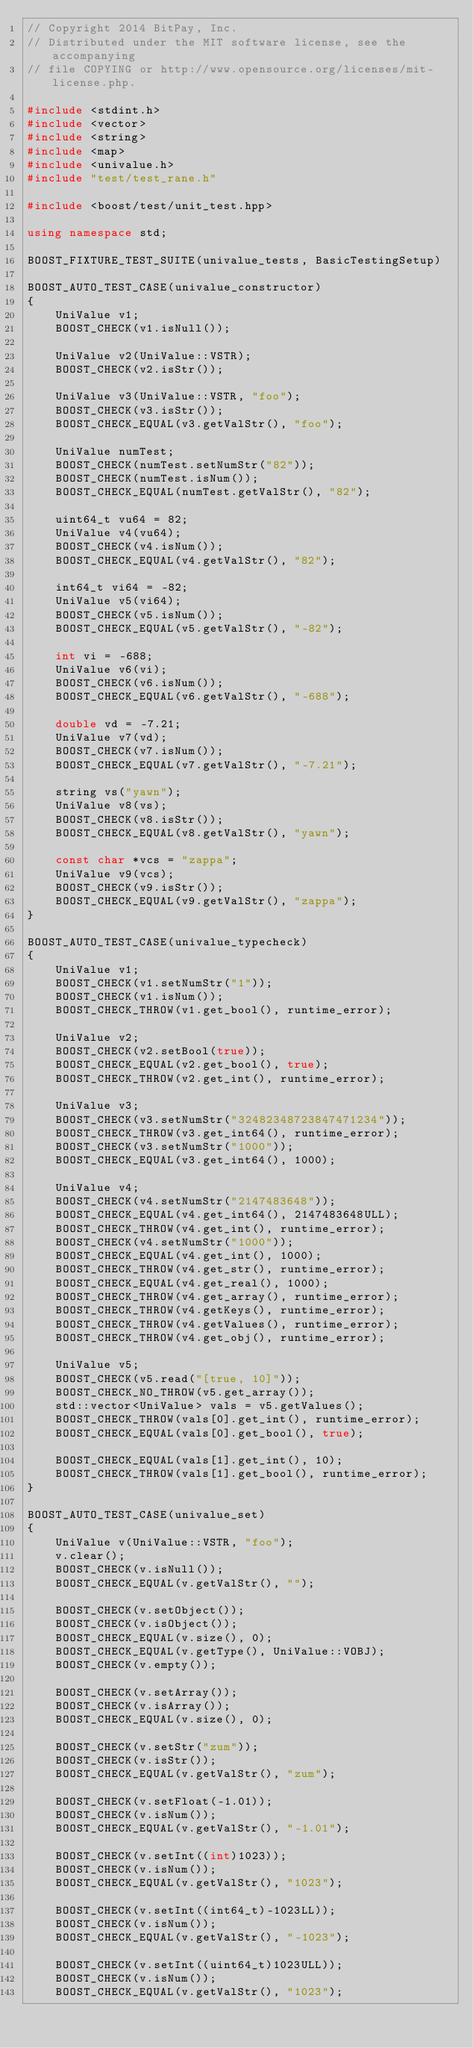Convert code to text. <code><loc_0><loc_0><loc_500><loc_500><_C++_>// Copyright 2014 BitPay, Inc.
// Distributed under the MIT software license, see the accompanying
// file COPYING or http://www.opensource.org/licenses/mit-license.php.

#include <stdint.h>
#include <vector>
#include <string>
#include <map>
#include <univalue.h>
#include "test/test_rane.h"

#include <boost/test/unit_test.hpp>

using namespace std;

BOOST_FIXTURE_TEST_SUITE(univalue_tests, BasicTestingSetup)

BOOST_AUTO_TEST_CASE(univalue_constructor)
{
    UniValue v1;
    BOOST_CHECK(v1.isNull());

    UniValue v2(UniValue::VSTR);
    BOOST_CHECK(v2.isStr());

    UniValue v3(UniValue::VSTR, "foo");
    BOOST_CHECK(v3.isStr());
    BOOST_CHECK_EQUAL(v3.getValStr(), "foo");

    UniValue numTest;
    BOOST_CHECK(numTest.setNumStr("82"));
    BOOST_CHECK(numTest.isNum());
    BOOST_CHECK_EQUAL(numTest.getValStr(), "82");

    uint64_t vu64 = 82;
    UniValue v4(vu64);
    BOOST_CHECK(v4.isNum());
    BOOST_CHECK_EQUAL(v4.getValStr(), "82");

    int64_t vi64 = -82;
    UniValue v5(vi64);
    BOOST_CHECK(v5.isNum());
    BOOST_CHECK_EQUAL(v5.getValStr(), "-82");

    int vi = -688;
    UniValue v6(vi);
    BOOST_CHECK(v6.isNum());
    BOOST_CHECK_EQUAL(v6.getValStr(), "-688");

    double vd = -7.21;
    UniValue v7(vd);
    BOOST_CHECK(v7.isNum());
    BOOST_CHECK_EQUAL(v7.getValStr(), "-7.21");

    string vs("yawn");
    UniValue v8(vs);
    BOOST_CHECK(v8.isStr());
    BOOST_CHECK_EQUAL(v8.getValStr(), "yawn");

    const char *vcs = "zappa";
    UniValue v9(vcs);
    BOOST_CHECK(v9.isStr());
    BOOST_CHECK_EQUAL(v9.getValStr(), "zappa");
}

BOOST_AUTO_TEST_CASE(univalue_typecheck)
{
    UniValue v1;
    BOOST_CHECK(v1.setNumStr("1"));
    BOOST_CHECK(v1.isNum());
    BOOST_CHECK_THROW(v1.get_bool(), runtime_error);

    UniValue v2;
    BOOST_CHECK(v2.setBool(true));
    BOOST_CHECK_EQUAL(v2.get_bool(), true);
    BOOST_CHECK_THROW(v2.get_int(), runtime_error);

    UniValue v3;
    BOOST_CHECK(v3.setNumStr("32482348723847471234"));
    BOOST_CHECK_THROW(v3.get_int64(), runtime_error);
    BOOST_CHECK(v3.setNumStr("1000"));
    BOOST_CHECK_EQUAL(v3.get_int64(), 1000);

    UniValue v4;
    BOOST_CHECK(v4.setNumStr("2147483648"));
    BOOST_CHECK_EQUAL(v4.get_int64(), 2147483648ULL);
    BOOST_CHECK_THROW(v4.get_int(), runtime_error);
    BOOST_CHECK(v4.setNumStr("1000"));
    BOOST_CHECK_EQUAL(v4.get_int(), 1000);
    BOOST_CHECK_THROW(v4.get_str(), runtime_error);
    BOOST_CHECK_EQUAL(v4.get_real(), 1000);
    BOOST_CHECK_THROW(v4.get_array(), runtime_error);
    BOOST_CHECK_THROW(v4.getKeys(), runtime_error);
    BOOST_CHECK_THROW(v4.getValues(), runtime_error);
    BOOST_CHECK_THROW(v4.get_obj(), runtime_error);

    UniValue v5;
    BOOST_CHECK(v5.read("[true, 10]"));
    BOOST_CHECK_NO_THROW(v5.get_array());
    std::vector<UniValue> vals = v5.getValues();
    BOOST_CHECK_THROW(vals[0].get_int(), runtime_error);
    BOOST_CHECK_EQUAL(vals[0].get_bool(), true);

    BOOST_CHECK_EQUAL(vals[1].get_int(), 10);
    BOOST_CHECK_THROW(vals[1].get_bool(), runtime_error);
}

BOOST_AUTO_TEST_CASE(univalue_set)
{
    UniValue v(UniValue::VSTR, "foo");
    v.clear();
    BOOST_CHECK(v.isNull());
    BOOST_CHECK_EQUAL(v.getValStr(), "");

    BOOST_CHECK(v.setObject());
    BOOST_CHECK(v.isObject());
    BOOST_CHECK_EQUAL(v.size(), 0);
    BOOST_CHECK_EQUAL(v.getType(), UniValue::VOBJ);
    BOOST_CHECK(v.empty());

    BOOST_CHECK(v.setArray());
    BOOST_CHECK(v.isArray());
    BOOST_CHECK_EQUAL(v.size(), 0);

    BOOST_CHECK(v.setStr("zum"));
    BOOST_CHECK(v.isStr());
    BOOST_CHECK_EQUAL(v.getValStr(), "zum");

    BOOST_CHECK(v.setFloat(-1.01));
    BOOST_CHECK(v.isNum());
    BOOST_CHECK_EQUAL(v.getValStr(), "-1.01");

    BOOST_CHECK(v.setInt((int)1023));
    BOOST_CHECK(v.isNum());
    BOOST_CHECK_EQUAL(v.getValStr(), "1023");

    BOOST_CHECK(v.setInt((int64_t)-1023LL));
    BOOST_CHECK(v.isNum());
    BOOST_CHECK_EQUAL(v.getValStr(), "-1023");

    BOOST_CHECK(v.setInt((uint64_t)1023ULL));
    BOOST_CHECK(v.isNum());
    BOOST_CHECK_EQUAL(v.getValStr(), "1023");
</code> 